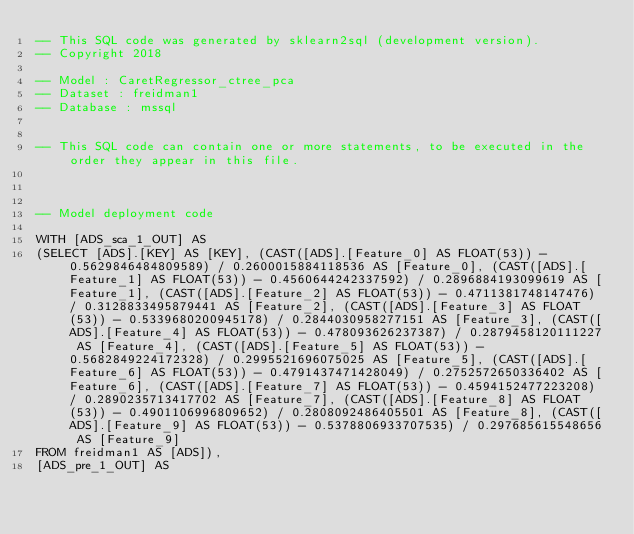<code> <loc_0><loc_0><loc_500><loc_500><_SQL_>-- This SQL code was generated by sklearn2sql (development version).
-- Copyright 2018

-- Model : CaretRegressor_ctree_pca
-- Dataset : freidman1
-- Database : mssql


-- This SQL code can contain one or more statements, to be executed in the order they appear in this file.



-- Model deployment code

WITH [ADS_sca_1_OUT] AS 
(SELECT [ADS].[KEY] AS [KEY], (CAST([ADS].[Feature_0] AS FLOAT(53)) - 0.5629846484809589) / 0.2600015884118536 AS [Feature_0], (CAST([ADS].[Feature_1] AS FLOAT(53)) - 0.4560644242337592) / 0.2896884193099619 AS [Feature_1], (CAST([ADS].[Feature_2] AS FLOAT(53)) - 0.4711381748147476) / 0.3128833495879441 AS [Feature_2], (CAST([ADS].[Feature_3] AS FLOAT(53)) - 0.5339680200945178) / 0.2844030958277151 AS [Feature_3], (CAST([ADS].[Feature_4] AS FLOAT(53)) - 0.478093626237387) / 0.2879458120111227 AS [Feature_4], (CAST([ADS].[Feature_5] AS FLOAT(53)) - 0.5682849224172328) / 0.2995521696075025 AS [Feature_5], (CAST([ADS].[Feature_6] AS FLOAT(53)) - 0.4791437471428049) / 0.2752572650336402 AS [Feature_6], (CAST([ADS].[Feature_7] AS FLOAT(53)) - 0.4594152477223208) / 0.2890235713417702 AS [Feature_7], (CAST([ADS].[Feature_8] AS FLOAT(53)) - 0.4901106996809652) / 0.2808092486405501 AS [Feature_8], (CAST([ADS].[Feature_9] AS FLOAT(53)) - 0.5378806933707535) / 0.297685615548656 AS [Feature_9] 
FROM freidman1 AS [ADS]), 
[ADS_pre_1_OUT] AS </code> 